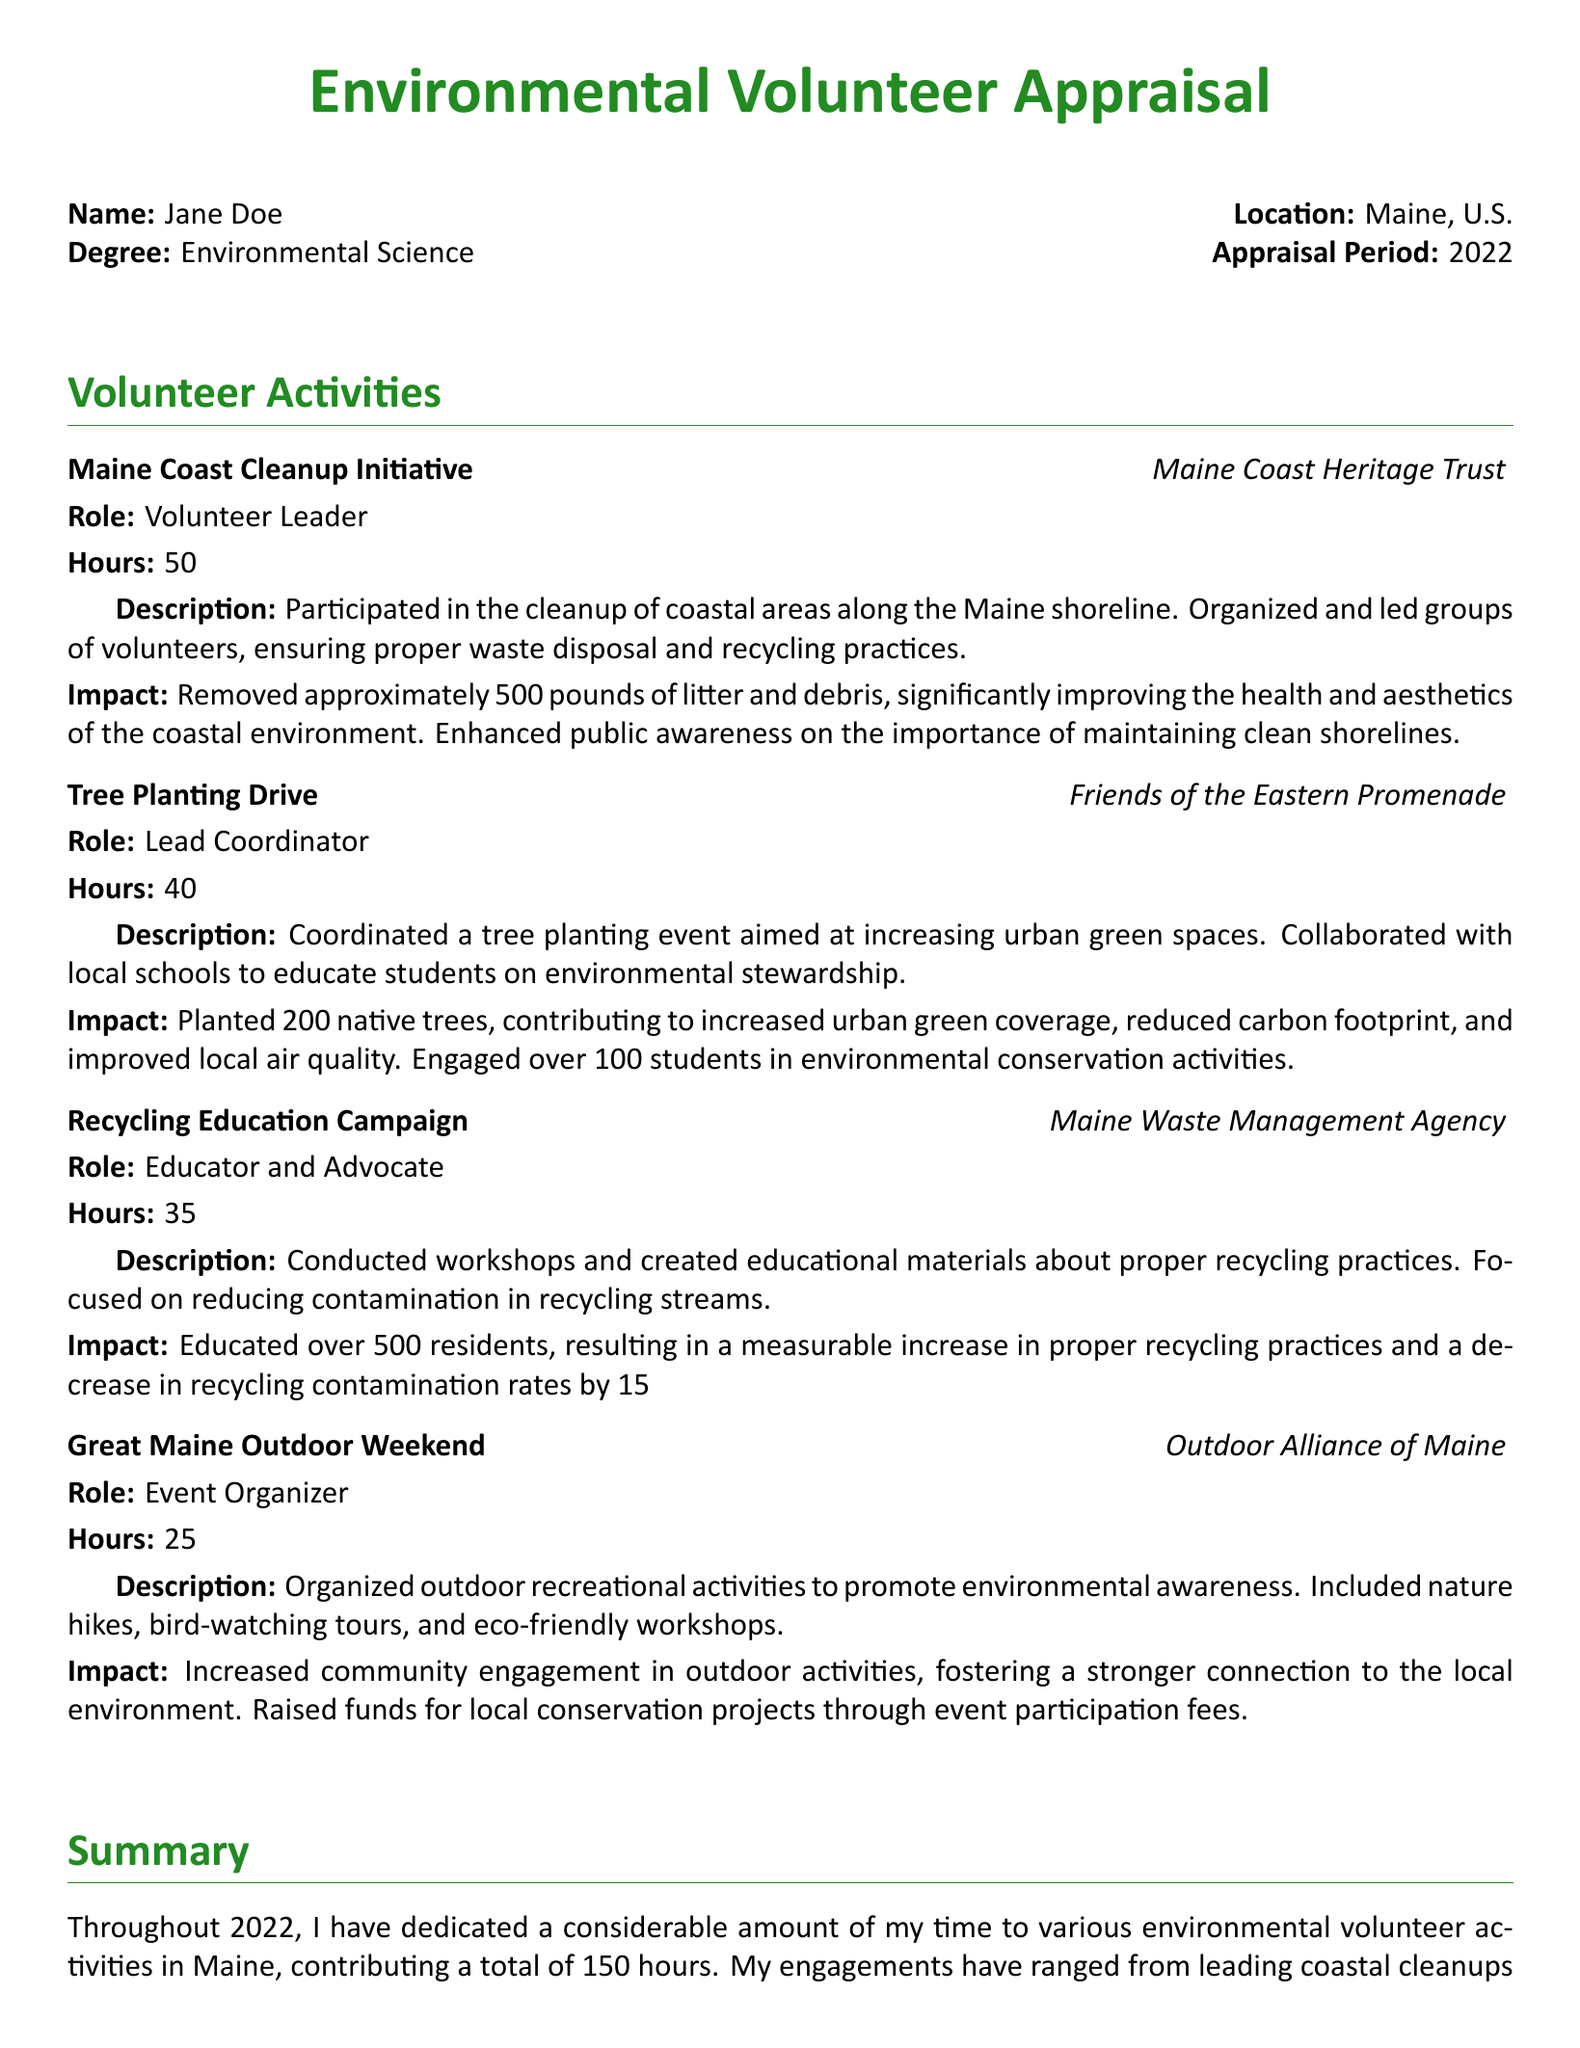What is the total number of volunteer hours contributed? The total number of volunteer hours is listed in the summary section of the document.
Answer: 150 Who was the lead coordinator for the Tree Planting Drive? The document identifies the lead coordinator for the Tree Planting Drive under the project entry.
Answer: Jane Doe How many native trees were planted during the Tree Planting Drive? The number of native trees planted is specified in the impact section of the Tree Planting Drive.
Answer: 200 What was the decrease in recycling contamination rates from the Recycling Education Campaign? The decrease in recycling contamination rates is mentioned in the impact description of the Recycling Education Campaign.
Answer: 15% What project involved educational workshops on recycling? The project that involved educational workshops is described in the relevant project entry.
Answer: Recycling Education Campaign How many residents were educated through the Recycling Education Campaign? The number of residents educated is detailed in the impact section of the project.
Answer: 500 Which organization led the Maine Coast Cleanup Initiative? The organization responsible for the Maine Coast Cleanup Initiative is mentioned in the project entry.
Answer: Maine Coast Heritage Trust What type of events were organized during the Great Maine Outdoor Weekend? The types of events organized are listed in the description of the Great Maine Outdoor Weekend project.
Answer: Outdoor recreational activities What was the role of Jane Doe in the Maine Coast Cleanup Initiative? Jane Doe's role is specified under the project entry for the Maine Coast Cleanup Initiative.
Answer: Volunteer Leader 